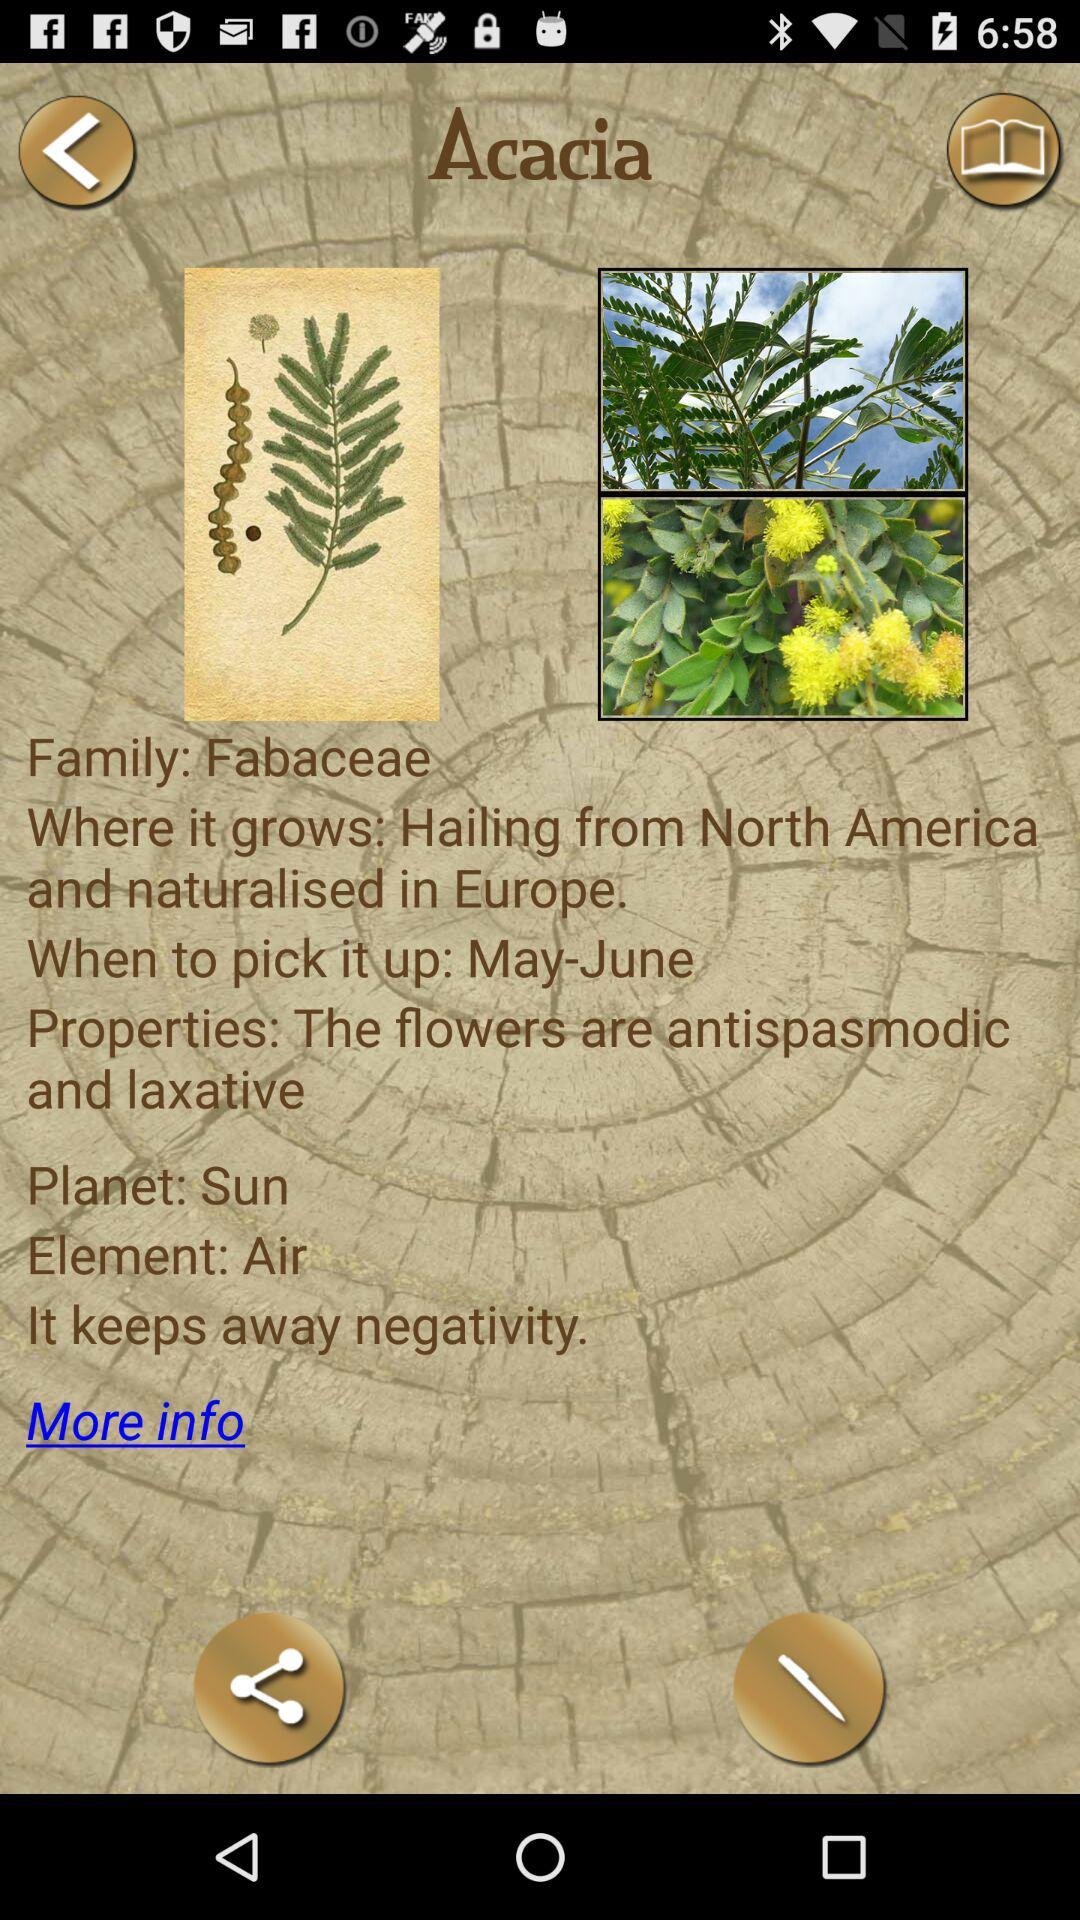What planet does the name Acacia represent? The name Acacia represents the Sun. 